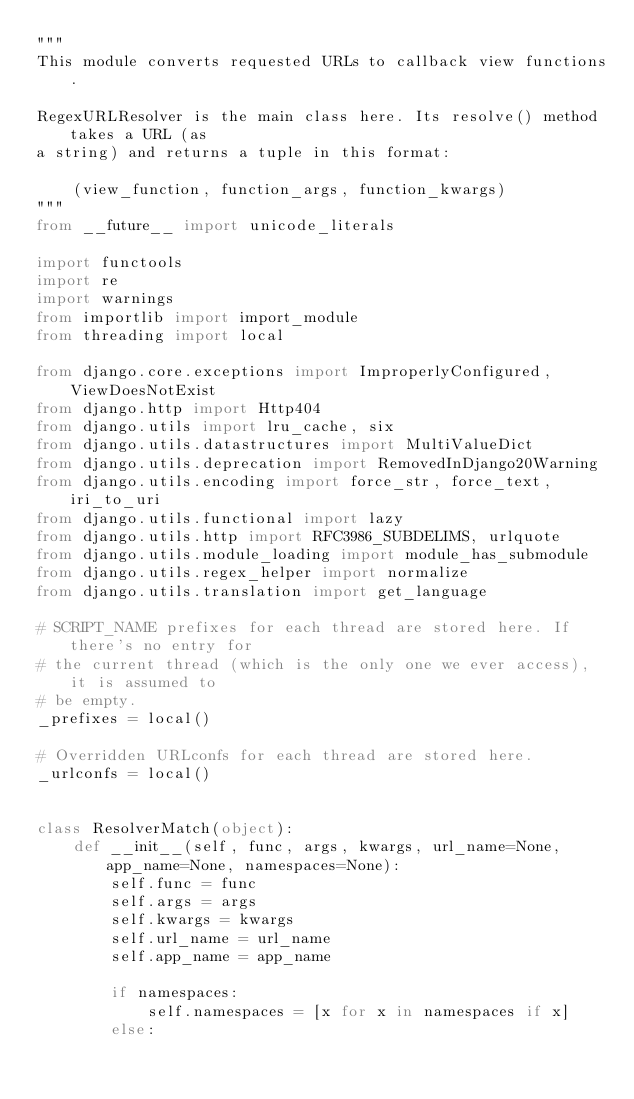<code> <loc_0><loc_0><loc_500><loc_500><_Python_>"""
This module converts requested URLs to callback view functions.

RegexURLResolver is the main class here. Its resolve() method takes a URL (as
a string) and returns a tuple in this format:

    (view_function, function_args, function_kwargs)
"""
from __future__ import unicode_literals

import functools
import re
import warnings
from importlib import import_module
from threading import local

from django.core.exceptions import ImproperlyConfigured, ViewDoesNotExist
from django.http import Http404
from django.utils import lru_cache, six
from django.utils.datastructures import MultiValueDict
from django.utils.deprecation import RemovedInDjango20Warning
from django.utils.encoding import force_str, force_text, iri_to_uri
from django.utils.functional import lazy
from django.utils.http import RFC3986_SUBDELIMS, urlquote
from django.utils.module_loading import module_has_submodule
from django.utils.regex_helper import normalize
from django.utils.translation import get_language

# SCRIPT_NAME prefixes for each thread are stored here. If there's no entry for
# the current thread (which is the only one we ever access), it is assumed to
# be empty.
_prefixes = local()

# Overridden URLconfs for each thread are stored here.
_urlconfs = local()


class ResolverMatch(object):
    def __init__(self, func, args, kwargs, url_name=None, app_name=None, namespaces=None):
        self.func = func
        self.args = args
        self.kwargs = kwargs
        self.url_name = url_name
        self.app_name = app_name

        if namespaces:
            self.namespaces = [x for x in namespaces if x]
        else:</code> 